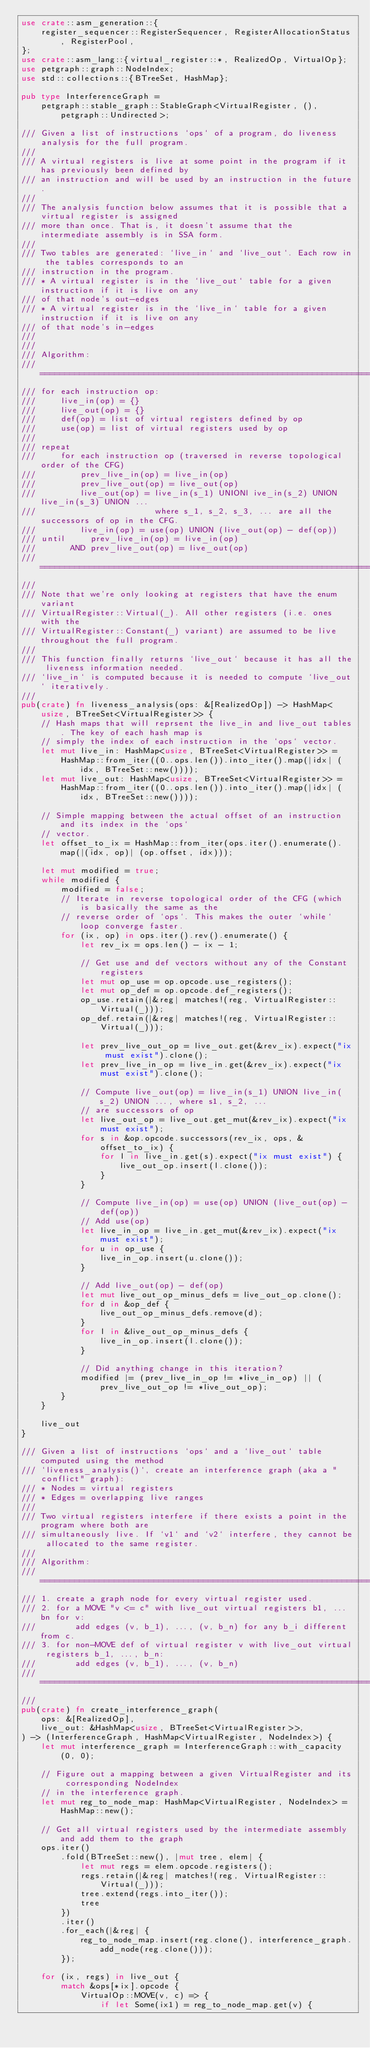<code> <loc_0><loc_0><loc_500><loc_500><_Rust_>use crate::asm_generation::{
    register_sequencer::RegisterSequencer, RegisterAllocationStatus, RegisterPool,
};
use crate::asm_lang::{virtual_register::*, RealizedOp, VirtualOp};
use petgraph::graph::NodeIndex;
use std::collections::{BTreeSet, HashMap};

pub type InterferenceGraph =
    petgraph::stable_graph::StableGraph<VirtualRegister, (), petgraph::Undirected>;

/// Given a list of instructions `ops` of a program, do liveness analysis for the full program.
///
/// A virtual registers is live at some point in the program if it has previously been defined by
/// an instruction and will be used by an instruction in the future.
///
/// The analysis function below assumes that it is possible that a virtual register is assigned
/// more than once. That is, it doesn't assume that the intermediate assembly is in SSA form.
///
/// Two tables are generated: `live_in` and `live_out`. Each row in the tables corresponds to an
/// instruction in the program.
/// * A virtual register is in the `live_out` table for a given instruction if it is live on any
/// of that node's out-edges
/// * A virtual register is in the `live_in` table for a given instruction if it is live on any
/// of that node's in-edges
///
///
/// Algorithm:
/// ===============================================================================================
/// for each instruction op:
///     live_in(op) = {}
///     live_out(op) = {}
///     def(op) = list of virtual registers defined by op
///     use(op) = list of virtual registers used by op
///
/// repeat
///     for each instruction op (traversed in reverse topological order of the CFG)
///         prev_live_in(op) = live_in(op)
///         prev_live_out(op) = live_out(op)
///         live_out(op) = live_in(s_1) UNIONl ive_in(s_2) UNION live_in(s_3) UNION ...
///                        where s_1, s_2, s_3, ... are all the successors of op in the CFG.
///         live_in(op) = use(op) UNION (live_out(op) - def(op))
/// until     prev_live_in(op) = live_in(op)
///       AND prev_live_out(op) = live_out(op)
/// ===============================================================================================
///
/// Note that we're only looking at registers that have the enum variant
/// VirtualRegister::Virtual(_). All other registers (i.e. ones with the
/// VirtualRegister::Constant(_) variant) are assumed to be live throughout the full program.
///
/// This function finally returns `live_out` because it has all the liveness information needed.
/// `live_in` is computed because it is needed to compute `live_out` iteratively.
///
pub(crate) fn liveness_analysis(ops: &[RealizedOp]) -> HashMap<usize, BTreeSet<VirtualRegister>> {
    // Hash maps that will reprsent the live_in and live_out tables. The key of each hash map is
    // simply the index of each instruction in the `ops` vector.
    let mut live_in: HashMap<usize, BTreeSet<VirtualRegister>> =
        HashMap::from_iter((0..ops.len()).into_iter().map(|idx| (idx, BTreeSet::new())));
    let mut live_out: HashMap<usize, BTreeSet<VirtualRegister>> =
        HashMap::from_iter((0..ops.len()).into_iter().map(|idx| (idx, BTreeSet::new())));

    // Simple mapping between the actual offset of an instruction and its index in the `ops`
    // vector.
    let offset_to_ix = HashMap::from_iter(ops.iter().enumerate().map(|(idx, op)| (op.offset, idx)));

    let mut modified = true;
    while modified {
        modified = false;
        // Iterate in reverse topological order of the CFG (which is basically the same as the
        // reverse order of `ops`. This makes the outer `while` loop converge faster.
        for (ix, op) in ops.iter().rev().enumerate() {
            let rev_ix = ops.len() - ix - 1;

            // Get use and def vectors without any of the Constant registers
            let mut op_use = op.opcode.use_registers();
            let mut op_def = op.opcode.def_registers();
            op_use.retain(|&reg| matches!(reg, VirtualRegister::Virtual(_)));
            op_def.retain(|&reg| matches!(reg, VirtualRegister::Virtual(_)));

            let prev_live_out_op = live_out.get(&rev_ix).expect("ix must exist").clone();
            let prev_live_in_op = live_in.get(&rev_ix).expect("ix must exist").clone();

            // Compute live_out(op) = live_in(s_1) UNION live_in(s_2) UNION ..., where s1, s_2, ...
            // are successors of op
            let live_out_op = live_out.get_mut(&rev_ix).expect("ix must exist");
            for s in &op.opcode.successors(rev_ix, ops, &offset_to_ix) {
                for l in live_in.get(s).expect("ix must exist") {
                    live_out_op.insert(l.clone());
                }
            }

            // Compute live_in(op) = use(op) UNION (live_out(op) - def(op))
            // Add use(op)
            let live_in_op = live_in.get_mut(&rev_ix).expect("ix must exist");
            for u in op_use {
                live_in_op.insert(u.clone());
            }

            // Add live_out(op) - def(op)
            let mut live_out_op_minus_defs = live_out_op.clone();
            for d in &op_def {
                live_out_op_minus_defs.remove(d);
            }
            for l in &live_out_op_minus_defs {
                live_in_op.insert(l.clone());
            }

            // Did anything change in this iteration?
            modified |= (prev_live_in_op != *live_in_op) || (prev_live_out_op != *live_out_op);
        }
    }

    live_out
}

/// Given a list of instructions `ops` and a `live_out` table computed using the method
/// `liveness_analysis()`, create an interference graph (aka a "conflict" graph):
/// * Nodes = virtual registers
/// * Edges = overlapping live ranges
///
/// Two virtual registers interfere if there exists a point in the program where both are
/// simultaneously live. If `v1` and `v2` interfere, they cannot be allocated to the same register.
///
/// Algorithm:
/// ===============================================================================================
/// 1. create a graph node for every virtual register used.
/// 2. for a MOVE "v <= c" with live_out virtual registers b1, ... bn for v:
///        add edges (v, b_1), ..., (v, b_n) for any b_i different from c.
/// 3. for non-MOVE def of virtual register v with live_out virtual registers b_1, ..., b_n:
///        add edges (v, b_1), ..., (v, b_n)
/// ===============================================================================================
///
pub(crate) fn create_interference_graph(
    ops: &[RealizedOp],
    live_out: &HashMap<usize, BTreeSet<VirtualRegister>>,
) -> (InterferenceGraph, HashMap<VirtualRegister, NodeIndex>) {
    let mut interference_graph = InterferenceGraph::with_capacity(0, 0);

    // Figure out a mapping between a given VirtualRegister and its corresponding NodeIndex
    // in the interference graph.
    let mut reg_to_node_map: HashMap<VirtualRegister, NodeIndex> = HashMap::new();

    // Get all virtual registers used by the intermediate assembly and add them to the graph
    ops.iter()
        .fold(BTreeSet::new(), |mut tree, elem| {
            let mut regs = elem.opcode.registers();
            regs.retain(|&reg| matches!(reg, VirtualRegister::Virtual(_)));
            tree.extend(regs.into_iter());
            tree
        })
        .iter()
        .for_each(|&reg| {
            reg_to_node_map.insert(reg.clone(), interference_graph.add_node(reg.clone()));
        });

    for (ix, regs) in live_out {
        match &ops[*ix].opcode {
            VirtualOp::MOVE(v, c) => {
                if let Some(ix1) = reg_to_node_map.get(v) {</code> 